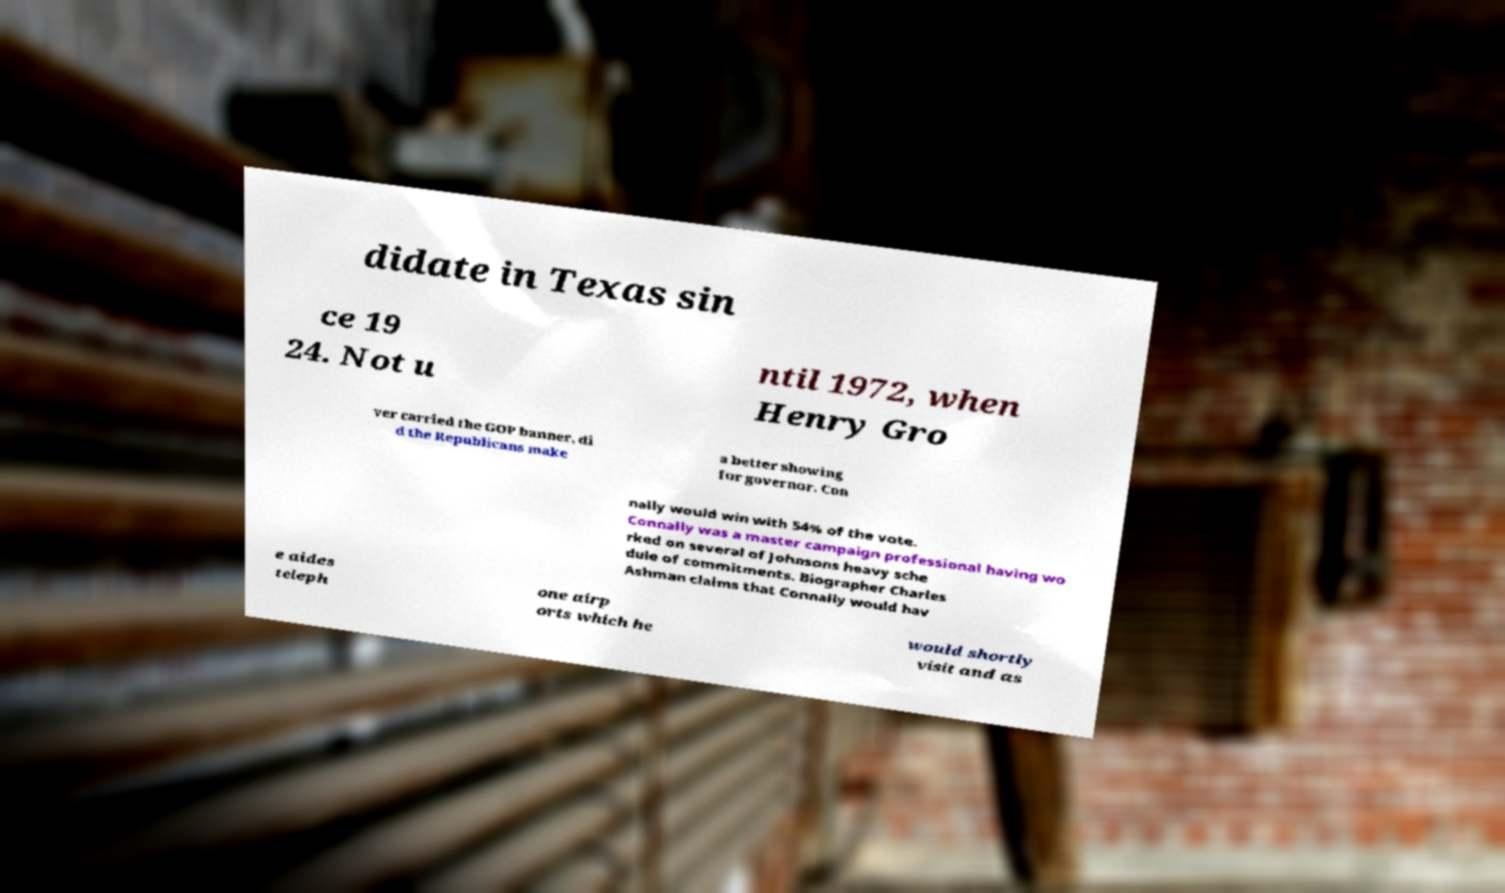There's text embedded in this image that I need extracted. Can you transcribe it verbatim? didate in Texas sin ce 19 24. Not u ntil 1972, when Henry Gro ver carried the GOP banner, di d the Republicans make a better showing for governor. Con nally would win with 54% of the vote. Connally was a master campaign professional having wo rked on several of Johnsons heavy sche dule of commitments. Biographer Charles Ashman claims that Connally would hav e aides teleph one airp orts which he would shortly visit and as 